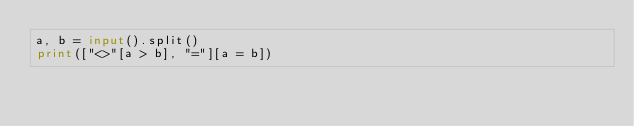Convert code to text. <code><loc_0><loc_0><loc_500><loc_500><_Python_>a, b = input().split()
print(["<>"[a > b], "="][a = b])</code> 